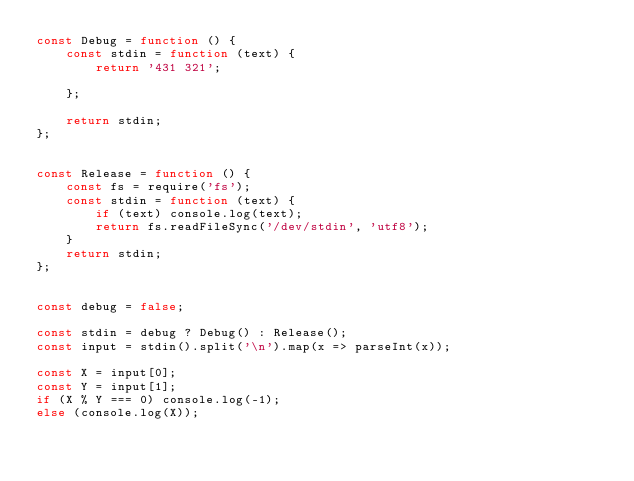<code> <loc_0><loc_0><loc_500><loc_500><_JavaScript_>const Debug = function () {
    const stdin = function (text) {
        return '431 321';

    };

    return stdin;
};


const Release = function () {
    const fs = require('fs');
    const stdin = function (text) {
        if (text) console.log(text);
        return fs.readFileSync('/dev/stdin', 'utf8');
    }
    return stdin;
};


const debug = false;

const stdin = debug ? Debug() : Release();
const input = stdin().split('\n').map(x => parseInt(x));

const X = input[0];
const Y = input[1];
if (X % Y === 0) console.log(-1);
else (console.log(X));

</code> 